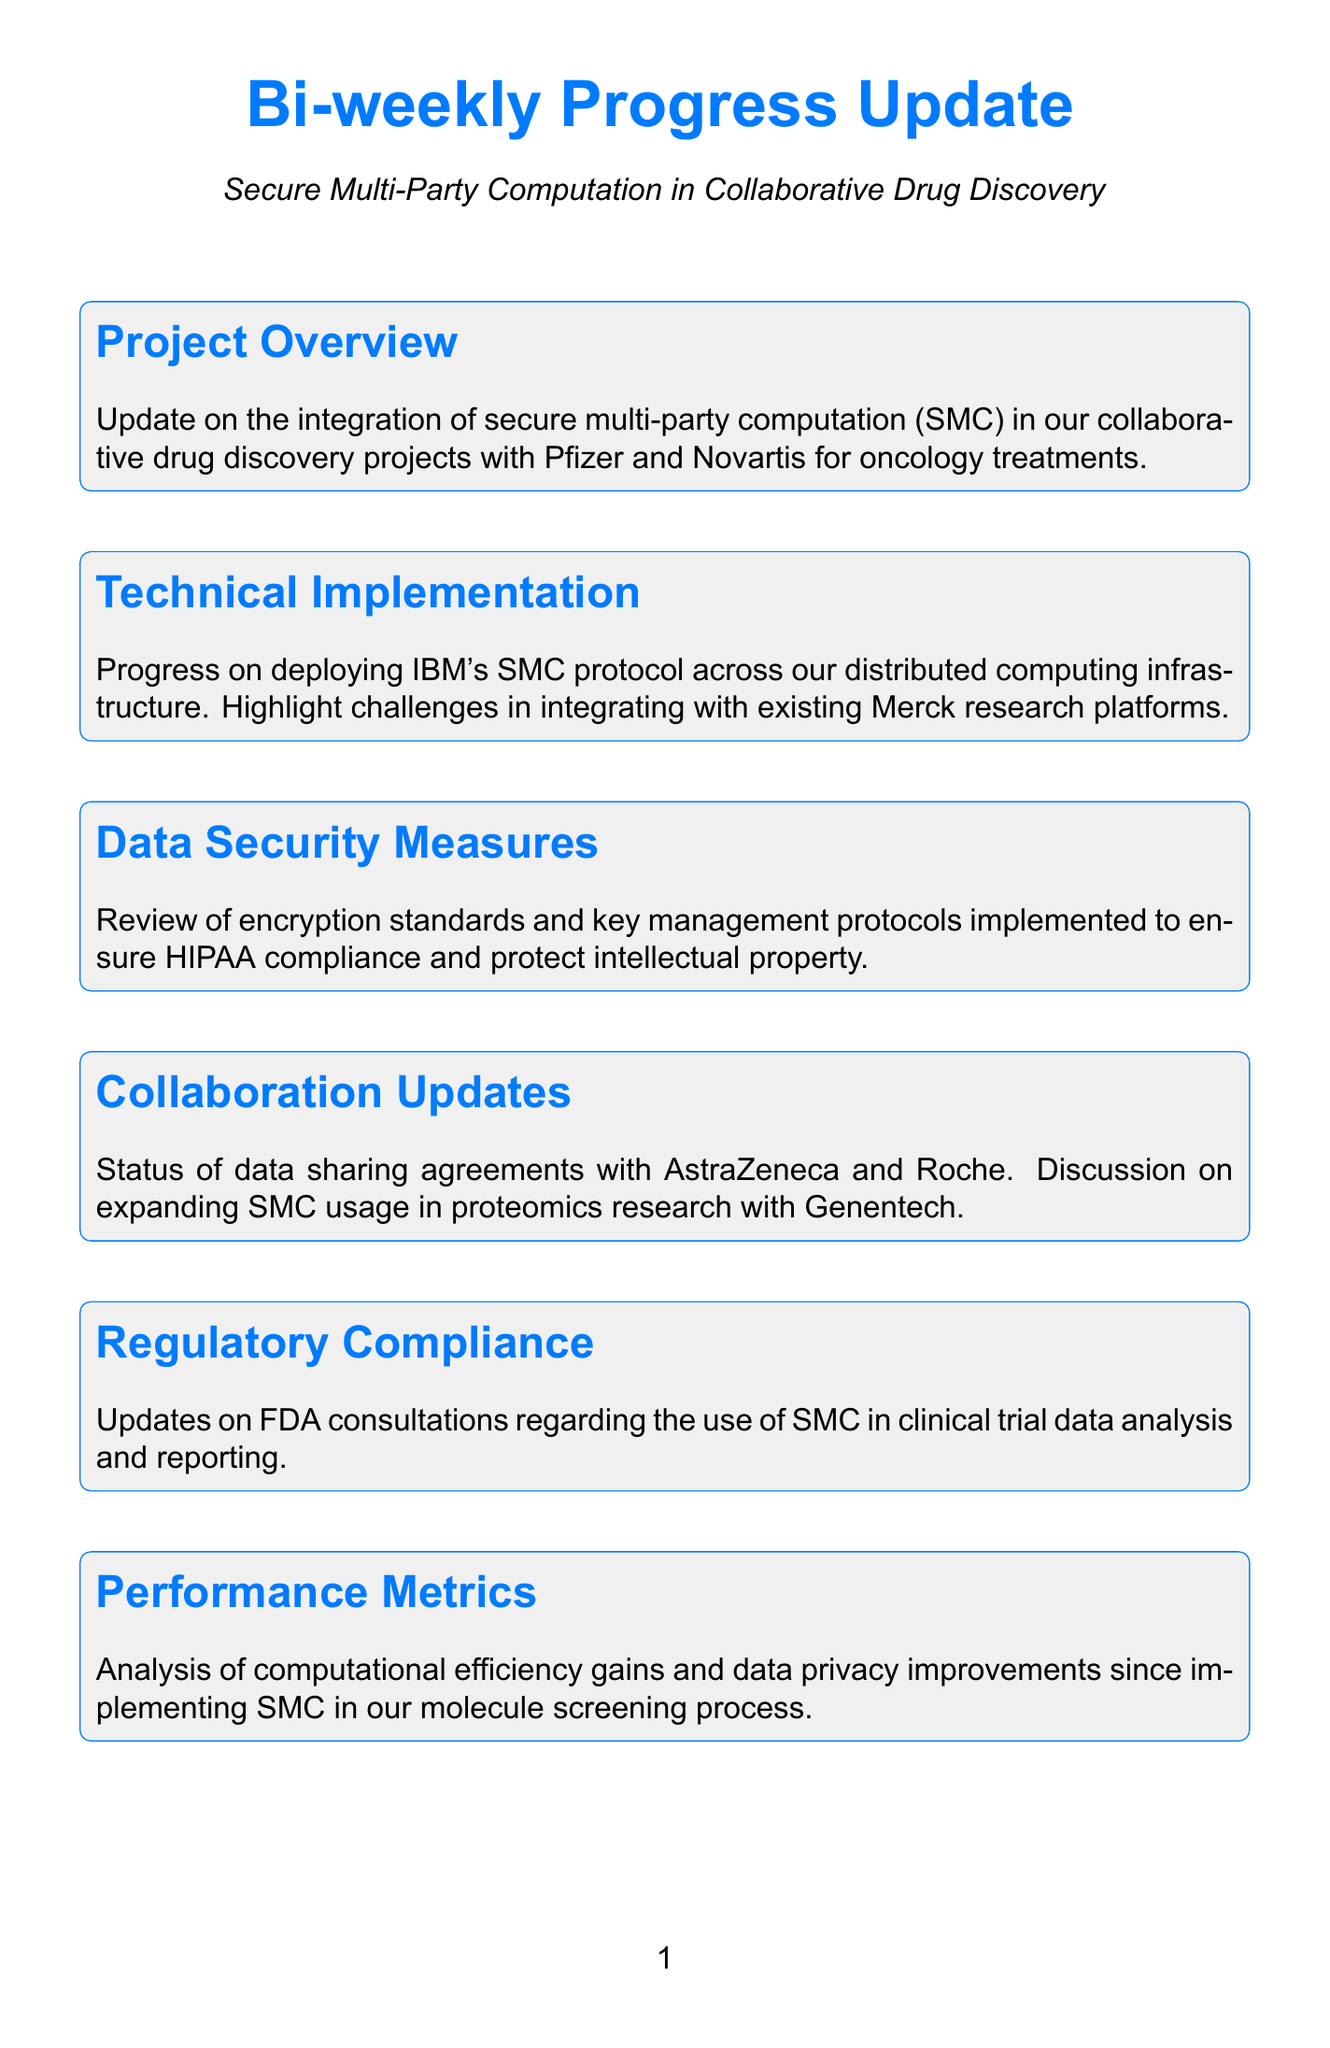what is the main focus of the project overview? The project overview focuses on the integration of secure multi-party computation (SMC) in collaborative drug discovery projects.
Answer: integration of secure multi-party computation (SMC) who are the collaborating companies mentioned in the project overview? The collaborating companies mentioned are Pfizer and Novartis.
Answer: Pfizer and Novartis which protocol is being deployed for the technical implementation? The protocol being deployed is IBM's SMC protocol.
Answer: IBM's SMC protocol what is the primary goal of the data security measures section? The primary goal of the data security measures section is to ensure HIPAA compliance and protect intellectual property.
Answer: ensure HIPAA compliance and protect intellectual property how many collaboration updates are provided in the document? There are three collaboration updates provided regarding data sharing agreements and discussion on SMC expansion with Genentech.
Answer: three what entity is involved in conducting third-party security audits? The entity involved in conducting third-party security audits is Deloitte.
Answer: Deloitte what is the status of employee training programs in relation to SMC protocols? The document discusses progress on employee training programs for SMC protocols.
Answer: progress which area of drug development is discussed for future roadmap expansion? The future roadmap discusses expanding SMC usage to pharmacovigilance and adverse event reporting.
Answer: pharmacovigilance and adverse event reporting what type of updates are included regarding regulatory compliance? The updates included are about FDA consultations related to SMC use in clinical trial data analysis.
Answer: FDA consultations how are performance metrics evaluated in the document? Performance metrics are evaluated based on computational efficiency gains and data privacy improvements.
Answer: computational efficiency gains and data privacy improvements 